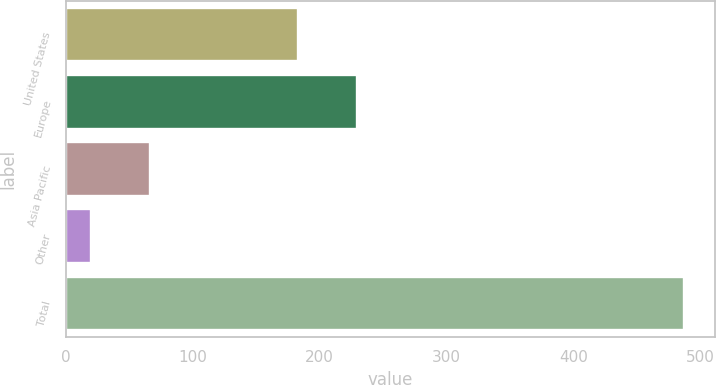Convert chart to OTSL. <chart><loc_0><loc_0><loc_500><loc_500><bar_chart><fcel>United States<fcel>Europe<fcel>Asia Pacific<fcel>Other<fcel>Total<nl><fcel>183<fcel>229.7<fcel>66.7<fcel>20<fcel>487<nl></chart> 